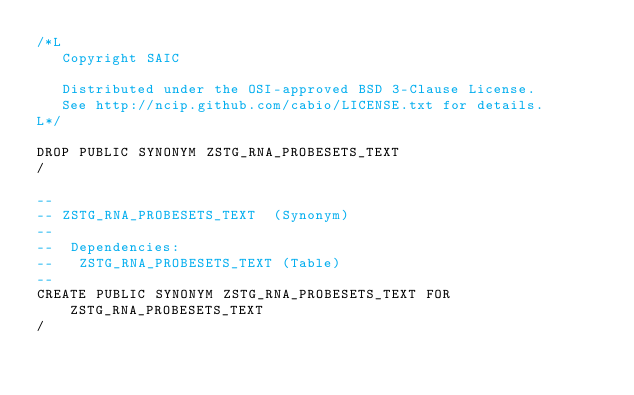Convert code to text. <code><loc_0><loc_0><loc_500><loc_500><_SQL_>/*L
   Copyright SAIC

   Distributed under the OSI-approved BSD 3-Clause License.
   See http://ncip.github.com/cabio/LICENSE.txt for details.
L*/

DROP PUBLIC SYNONYM ZSTG_RNA_PROBESETS_TEXT
/

--
-- ZSTG_RNA_PROBESETS_TEXT  (Synonym) 
--
--  Dependencies: 
--   ZSTG_RNA_PROBESETS_TEXT (Table)
--
CREATE PUBLIC SYNONYM ZSTG_RNA_PROBESETS_TEXT FOR ZSTG_RNA_PROBESETS_TEXT
/


</code> 